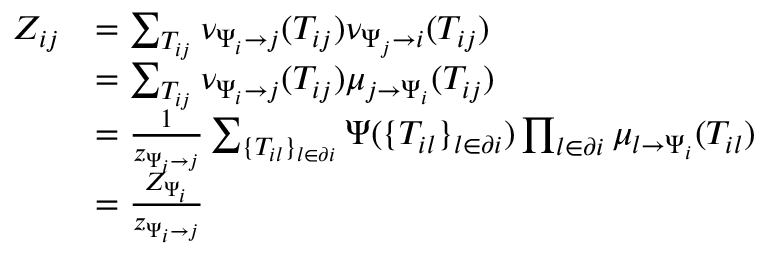Convert formula to latex. <formula><loc_0><loc_0><loc_500><loc_500>\begin{array} { r } { \begin{array} { r l } { Z _ { i j } } & { = \sum _ { T _ { i j } } \nu _ { \Psi _ { i } \to j } ( T _ { i j } ) \nu _ { \Psi _ { j } \to i } ( T _ { i j } ) } \\ & { = \sum _ { T _ { i j } } \nu _ { \Psi _ { i } \to j } ( T _ { i j } ) \mu _ { j \to \Psi _ { i } } ( T _ { i j } ) } \\ & { = \frac { 1 } { z _ { \Psi _ { i } \to j } } \sum _ { \{ T _ { i l } \} _ { l \in \partial i } } \Psi ( \{ T _ { i l } \} _ { l \in \partial i } ) \prod _ { l \in \partial i } \mu _ { l \to \Psi _ { i } } ( T _ { i l } ) } \\ & { = \frac { Z _ { \Psi _ { i } } } { z _ { \Psi _ { i } \to j } } } \end{array} } \end{array}</formula> 